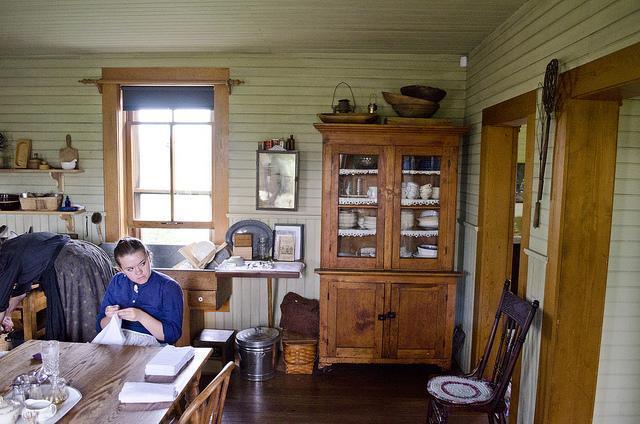What is this woman doing?
Choose the right answer from the provided options to respond to the question.
Options: Sewing, folding napkins, tearing, plaiting. Folding napkins. 